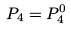<formula> <loc_0><loc_0><loc_500><loc_500>P _ { 4 } = P _ { 4 } ^ { 0 }</formula> 